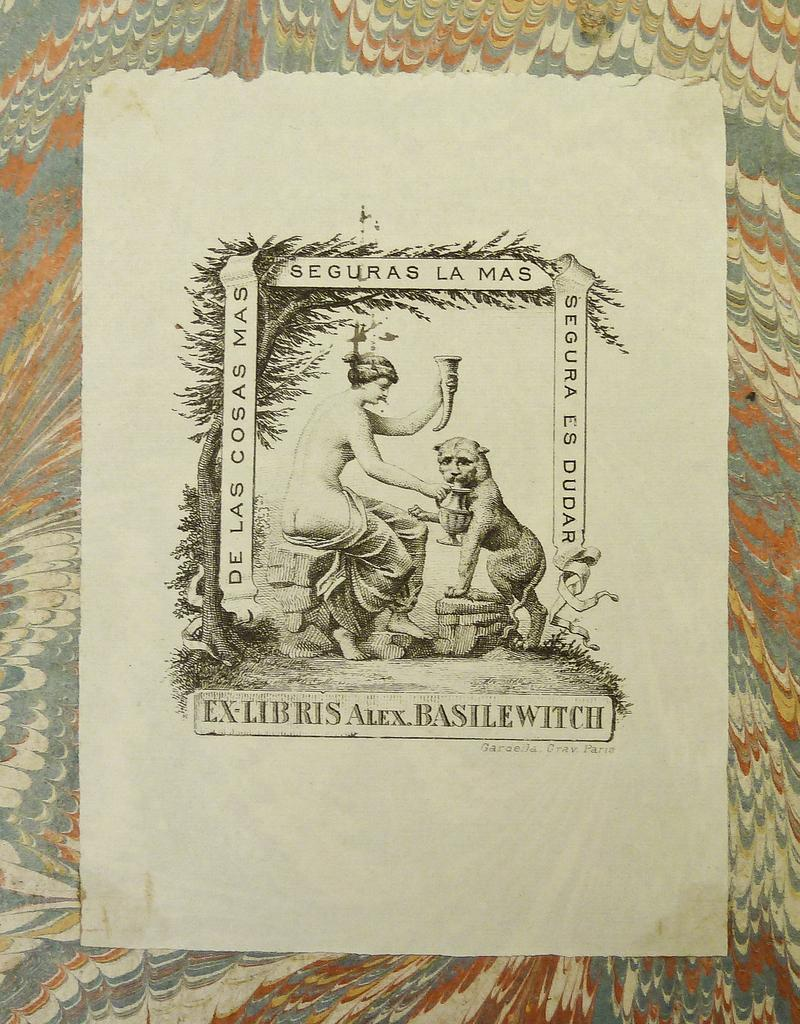<image>
Share a concise interpretation of the image provided. a picture of a woman and a beast with the word EX-LIBRIS on it 